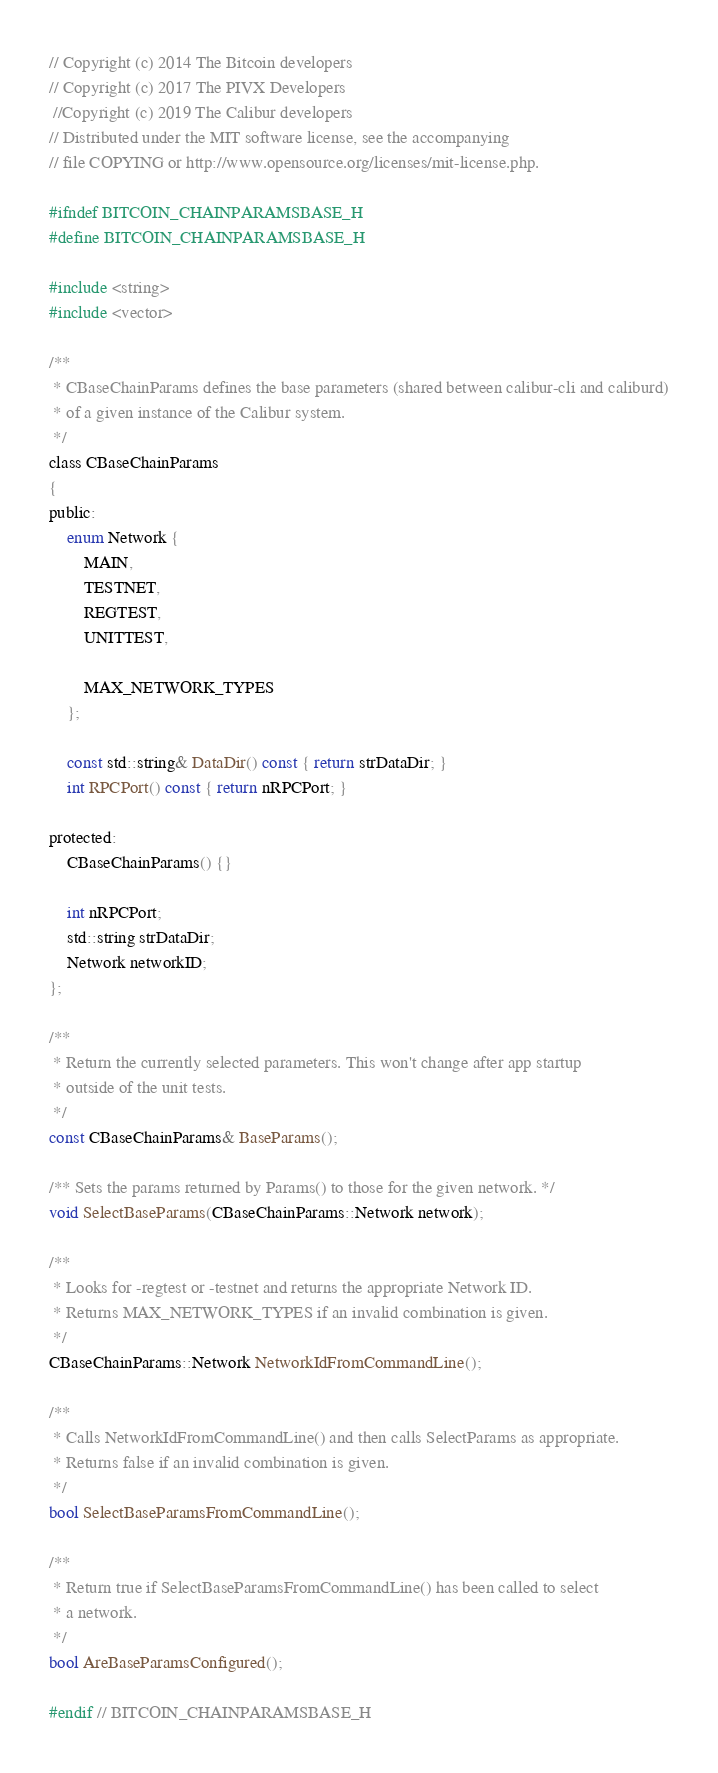Convert code to text. <code><loc_0><loc_0><loc_500><loc_500><_C_>// Copyright (c) 2014 The Bitcoin developers
// Copyright (c) 2017 The PIVX Developers 
 //Copyright (c) 2019 The Calibur developers
// Distributed under the MIT software license, see the accompanying
// file COPYING or http://www.opensource.org/licenses/mit-license.php.

#ifndef BITCOIN_CHAINPARAMSBASE_H
#define BITCOIN_CHAINPARAMSBASE_H

#include <string>
#include <vector>

/**
 * CBaseChainParams defines the base parameters (shared between calibur-cli and caliburd)
 * of a given instance of the Calibur system.
 */
class CBaseChainParams
{
public:
    enum Network {
        MAIN,
        TESTNET,
        REGTEST,
        UNITTEST,

        MAX_NETWORK_TYPES
    };

    const std::string& DataDir() const { return strDataDir; }
    int RPCPort() const { return nRPCPort; }

protected:
    CBaseChainParams() {}

    int nRPCPort;
    std::string strDataDir;
    Network networkID;
};

/**
 * Return the currently selected parameters. This won't change after app startup
 * outside of the unit tests.
 */
const CBaseChainParams& BaseParams();

/** Sets the params returned by Params() to those for the given network. */
void SelectBaseParams(CBaseChainParams::Network network);

/**
 * Looks for -regtest or -testnet and returns the appropriate Network ID.
 * Returns MAX_NETWORK_TYPES if an invalid combination is given.
 */
CBaseChainParams::Network NetworkIdFromCommandLine();

/**
 * Calls NetworkIdFromCommandLine() and then calls SelectParams as appropriate.
 * Returns false if an invalid combination is given.
 */
bool SelectBaseParamsFromCommandLine();

/**
 * Return true if SelectBaseParamsFromCommandLine() has been called to select
 * a network.
 */
bool AreBaseParamsConfigured();

#endif // BITCOIN_CHAINPARAMSBASE_H
</code> 